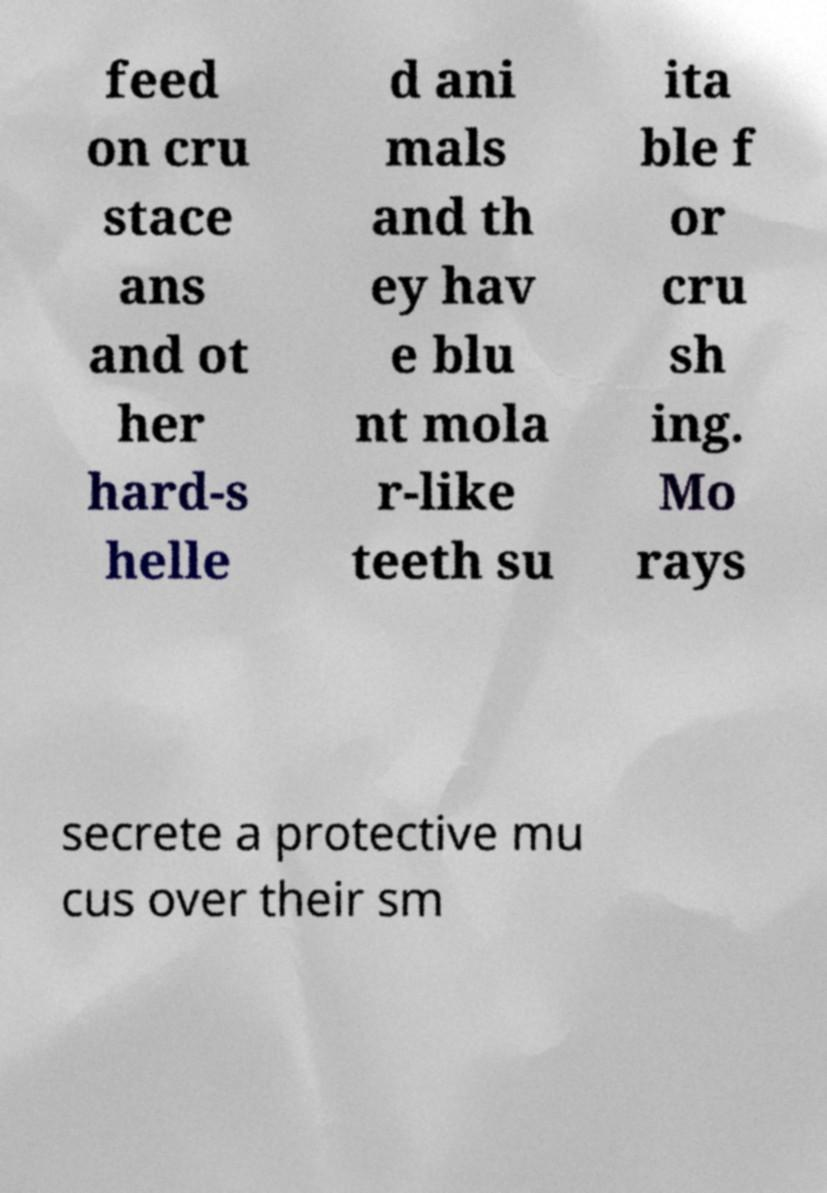Could you extract and type out the text from this image? feed on cru stace ans and ot her hard-s helle d ani mals and th ey hav e blu nt mola r-like teeth su ita ble f or cru sh ing. Mo rays secrete a protective mu cus over their sm 